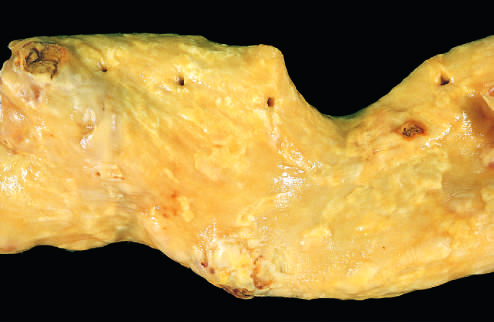s the aorta with mild atherosclerosis composed of fibrous plaques?
Answer the question using a single word or phrase. Yes 